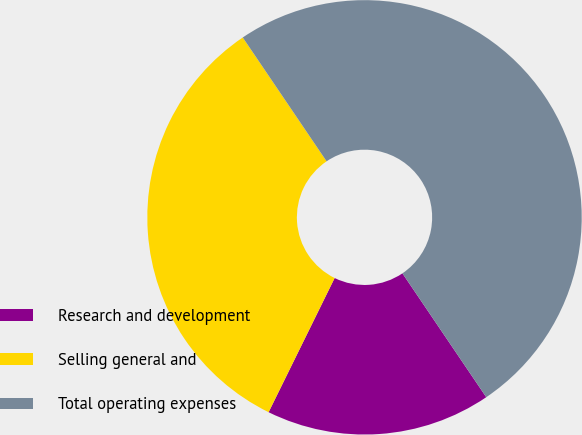<chart> <loc_0><loc_0><loc_500><loc_500><pie_chart><fcel>Research and development<fcel>Selling general and<fcel>Total operating expenses<nl><fcel>16.75%<fcel>33.25%<fcel>50.0%<nl></chart> 